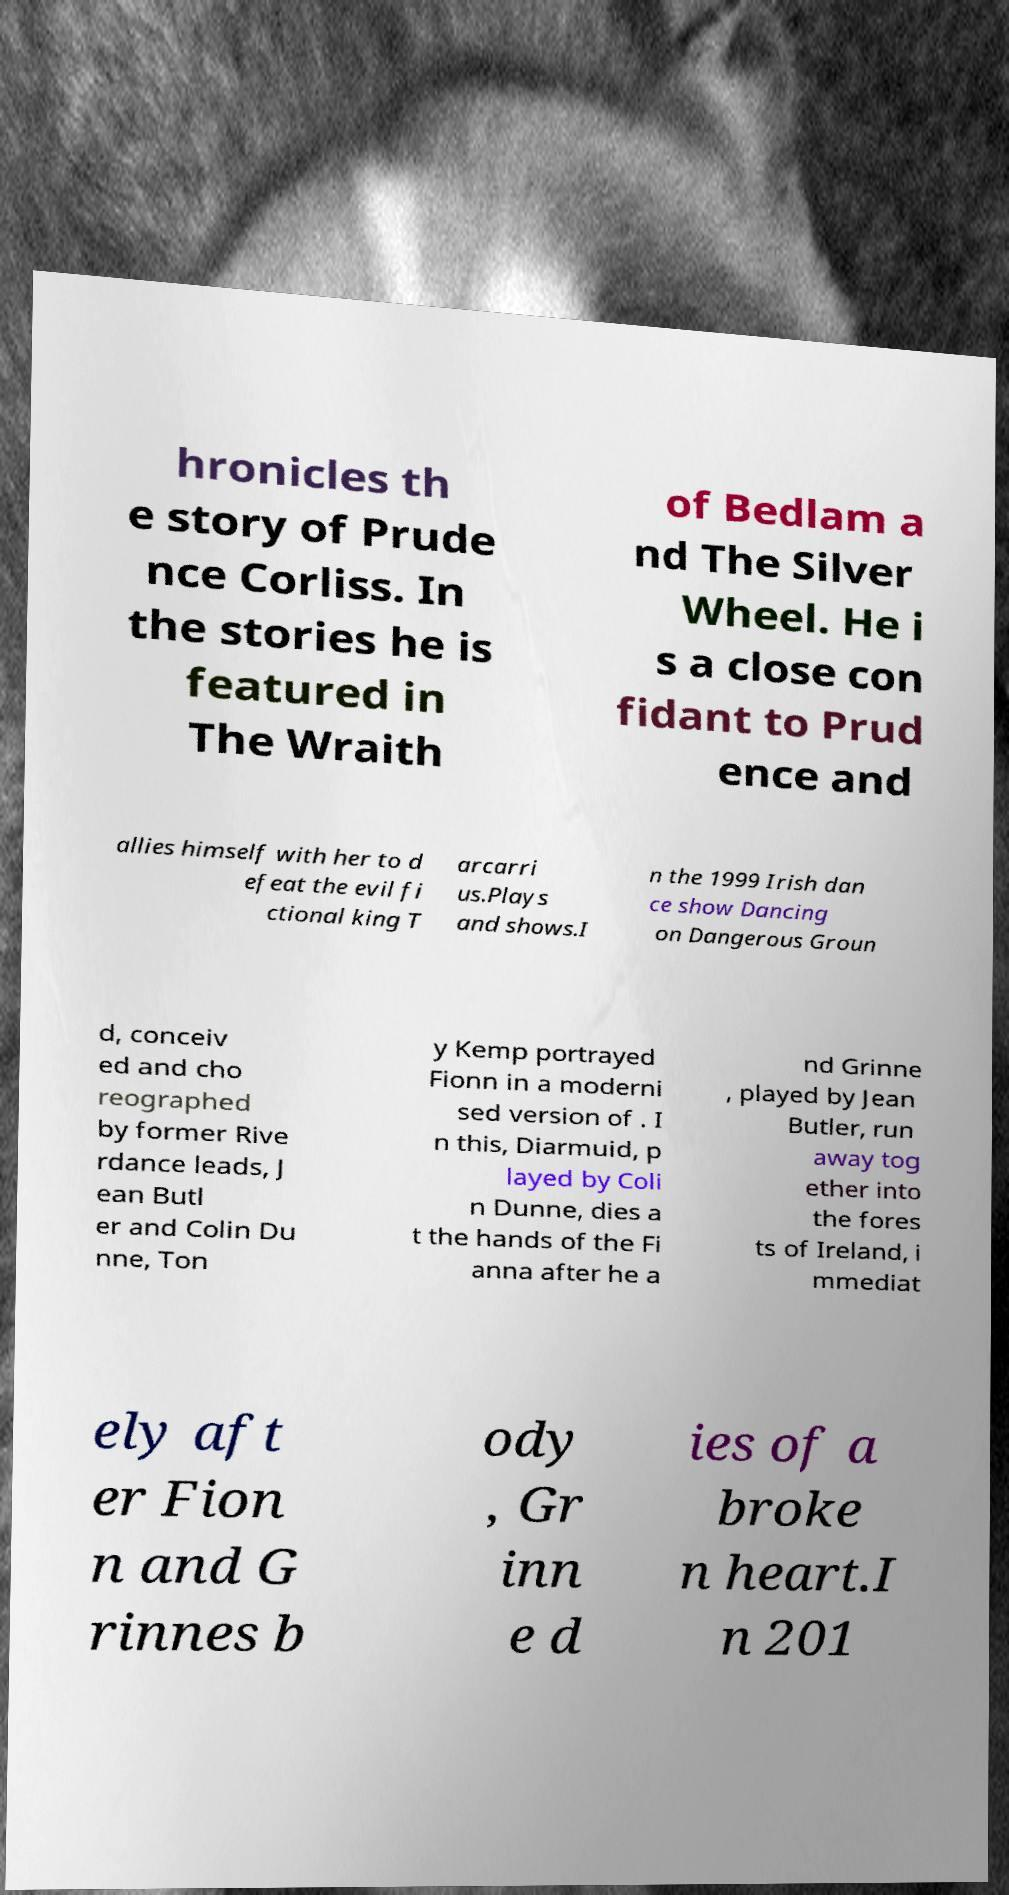Please identify and transcribe the text found in this image. hronicles th e story of Prude nce Corliss. In the stories he is featured in The Wraith of Bedlam a nd The Silver Wheel. He i s a close con fidant to Prud ence and allies himself with her to d efeat the evil fi ctional king T arcarri us.Plays and shows.I n the 1999 Irish dan ce show Dancing on Dangerous Groun d, conceiv ed and cho reographed by former Rive rdance leads, J ean Butl er and Colin Du nne, Ton y Kemp portrayed Fionn in a moderni sed version of . I n this, Diarmuid, p layed by Coli n Dunne, dies a t the hands of the Fi anna after he a nd Grinne , played by Jean Butler, run away tog ether into the fores ts of Ireland, i mmediat ely aft er Fion n and G rinnes b ody , Gr inn e d ies of a broke n heart.I n 201 